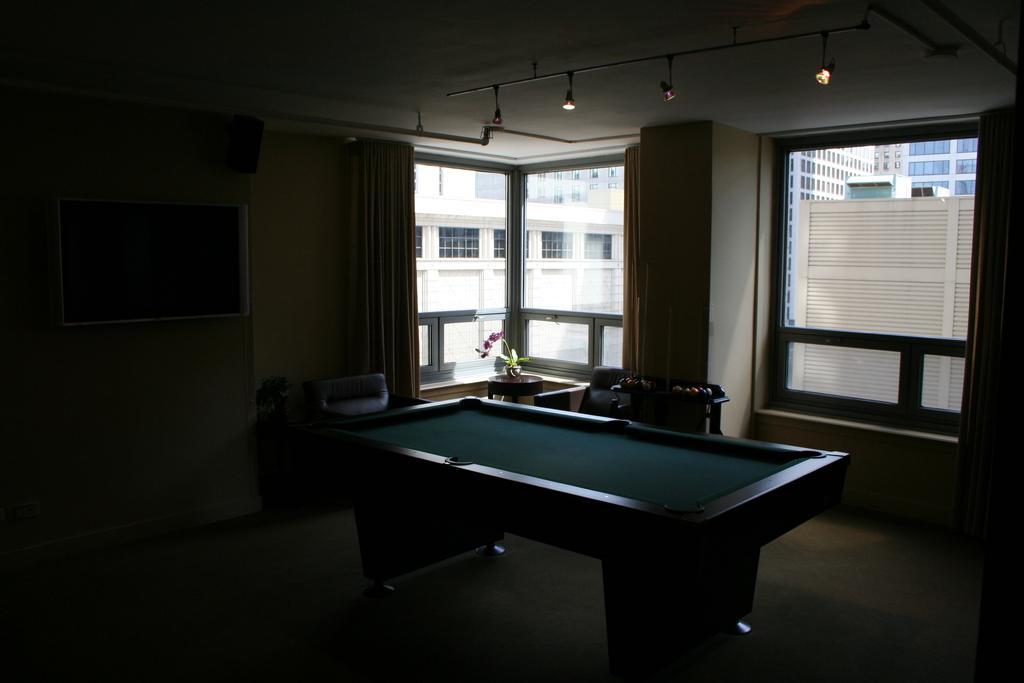Please provide a concise description of this image. There is a billiards table,curtains,balls on a table,flower vase,frame on the wall an window in this room. Through window we can see buildings. 